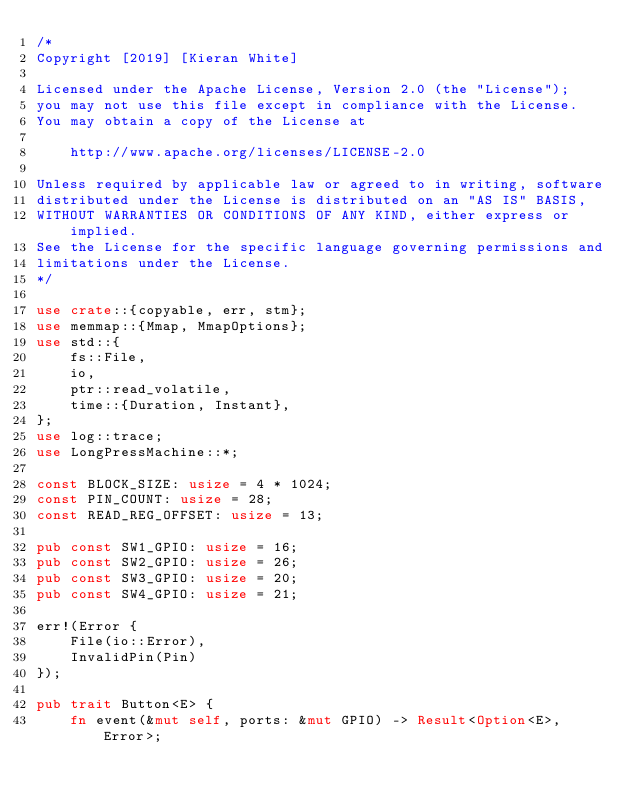Convert code to text. <code><loc_0><loc_0><loc_500><loc_500><_Rust_>/*
Copyright [2019] [Kieran White]

Licensed under the Apache License, Version 2.0 (the "License");
you may not use this file except in compliance with the License.
You may obtain a copy of the License at

    http://www.apache.org/licenses/LICENSE-2.0

Unless required by applicable law or agreed to in writing, software
distributed under the License is distributed on an "AS IS" BASIS,
WITHOUT WARRANTIES OR CONDITIONS OF ANY KIND, either express or implied.
See the License for the specific language governing permissions and
limitations under the License.
*/

use crate::{copyable, err, stm};
use memmap::{Mmap, MmapOptions};
use std::{
    fs::File,
    io,
    ptr::read_volatile,
    time::{Duration, Instant},
};
use log::trace;
use LongPressMachine::*;

const BLOCK_SIZE: usize = 4 * 1024;
const PIN_COUNT: usize = 28;
const READ_REG_OFFSET: usize = 13;

pub const SW1_GPIO: usize = 16;
pub const SW2_GPIO: usize = 26;
pub const SW3_GPIO: usize = 20;
pub const SW4_GPIO: usize = 21;

err!(Error {
    File(io::Error),
    InvalidPin(Pin)
});

pub trait Button<E> {
    fn event(&mut self, ports: &mut GPIO) -> Result<Option<E>, Error>;</code> 